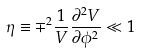Convert formula to latex. <formula><loc_0><loc_0><loc_500><loc_500>\eta \equiv \mp ^ { 2 } \frac { 1 } { V } \frac { \partial ^ { 2 } V } { \partial \phi ^ { 2 } } \ll 1</formula> 